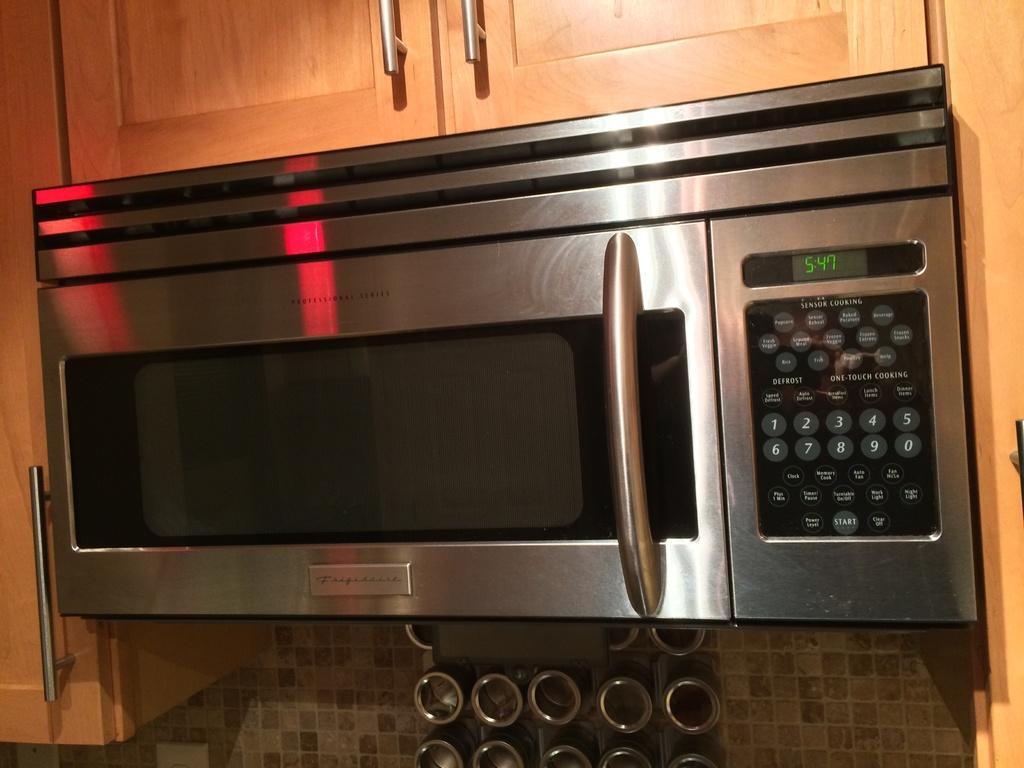What type of appliance is in the picture? There is an oven in the picture. What feature does the oven have? The oven has a door. Where are the buttons located on the oven? The buttons are on the right side of the oven. What is associated with the buttons on the oven? There is a display screen associated with the buttons. What is around the oven in the picture? There are shelves around the oven. Who is the creator of the sidewalk in the image? There is no sidewalk present in the image, so it is not possible to determine who the creator might be. 